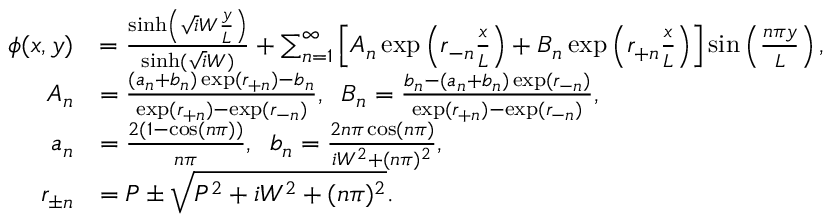<formula> <loc_0><loc_0><loc_500><loc_500>\begin{array} { r l } { \phi ( x , y ) } & { = \frac { \sinh \left ( \sqrt { i } W \frac { y } { L } \right ) } { \sinh ( \sqrt { i } W ) } + \sum _ { n = 1 } ^ { \infty } \left [ A _ { n } \exp \left ( r _ { - n } \frac { x } { L } \right ) + B _ { n } \exp \left ( r _ { + n } \frac { x } { L } \right ) \right ] \sin \left ( \frac { n \pi y } { L } \right ) , } \\ { A _ { n } } & { = \frac { ( a _ { n } + b _ { n } ) \exp ( r _ { + n } ) - b _ { n } } { \exp ( r _ { + n } ) - \exp ( r _ { - n } ) } , \, B _ { n } = \frac { b _ { n } - ( a _ { n } + b _ { n } ) \exp ( r _ { - n } ) } { \exp ( r _ { + n } ) - \exp ( r _ { - n } ) } , } \\ { a _ { n } } & { = \frac { 2 ( 1 - \cos ( n \pi ) ) } { n \pi } , \, b _ { n } = \frac { 2 n \pi \cos ( n \pi ) } { i W ^ { 2 } + ( n \pi ) ^ { 2 } } , } \\ { r _ { \pm n } } & { = P \pm \sqrt { P ^ { 2 } + i W ^ { 2 } + ( n \pi ) ^ { 2 } } . } \end{array}</formula> 